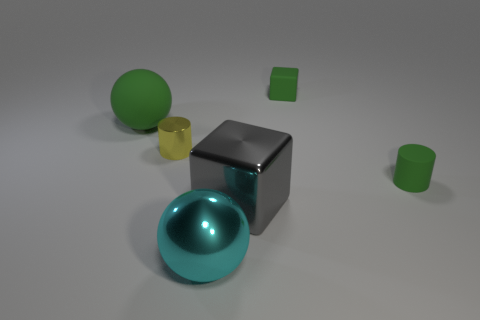Is there a big red object? no 